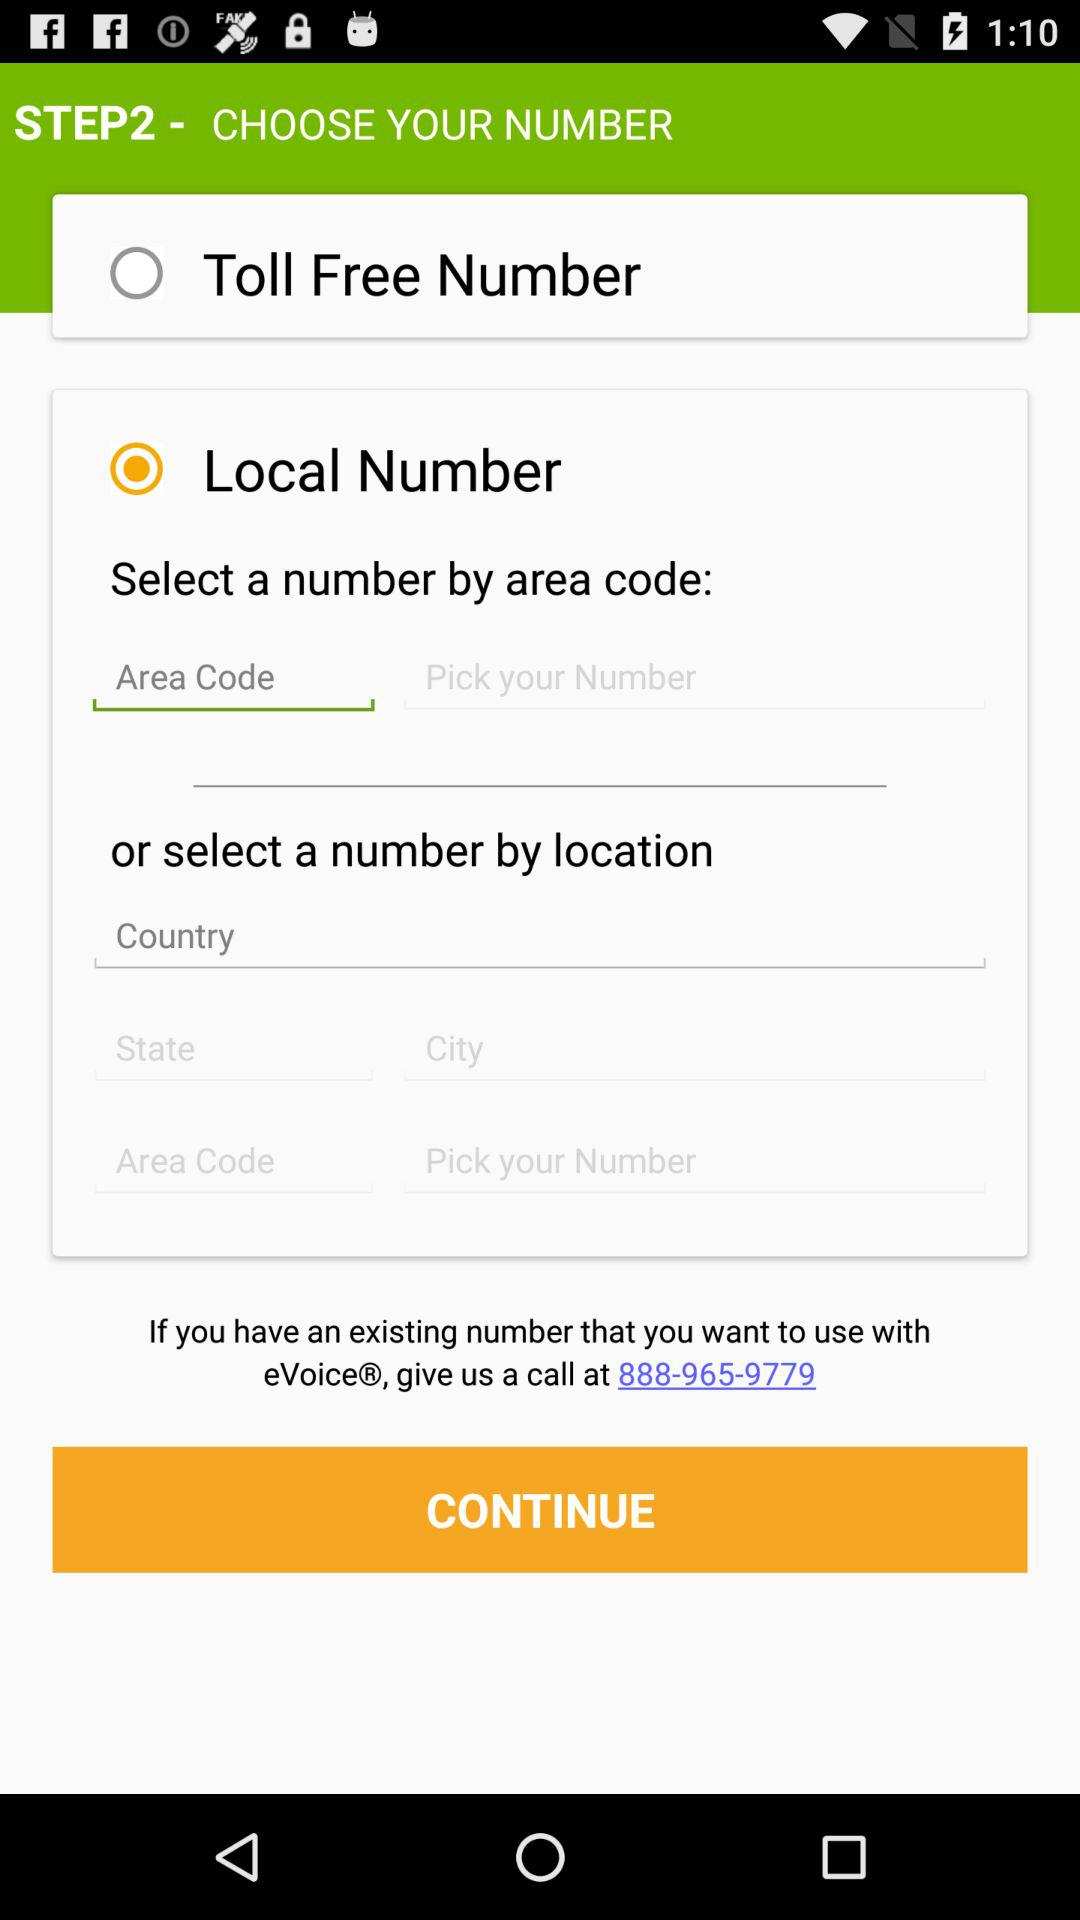What is the toll free number?
When the provided information is insufficient, respond with <no answer>. <no answer> 